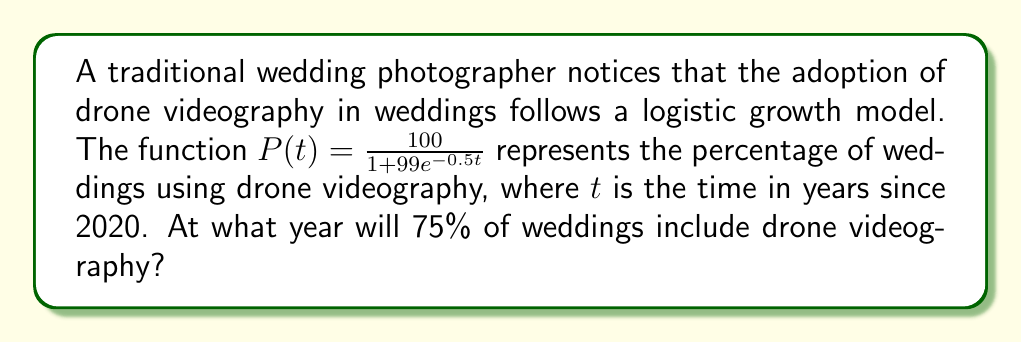Can you answer this question? To solve this problem, we need to follow these steps:

1) The logistic growth function is given by:
   $$P(t) = \frac{100}{1 + 99e^{-0.5t}}$$

2) We want to find when $P(t) = 75$. So, we set up the equation:
   $$75 = \frac{100}{1 + 99e^{-0.5t}}$$

3) Multiply both sides by $(1 + 99e^{-0.5t})$:
   $$75(1 + 99e^{-0.5t}) = 100$$

4) Expand the left side:
   $$75 + 7425e^{-0.5t} = 100$$

5) Subtract 75 from both sides:
   $$7425e^{-0.5t} = 25$$

6) Divide both sides by 7425:
   $$e^{-0.5t} = \frac{25}{7425} = \frac{1}{297}$$

7) Take the natural log of both sides:
   $$-0.5t = \ln(\frac{1}{297})$$

8) Divide both sides by -0.5:
   $$t = -\frac{\ln(\frac{1}{297})}{0.5} = \frac{\ln(297)}{0.5} \approx 11.46$$

9) Since $t$ is the number of years since 2020, we add 11.46 to 2020:
   $$2020 + 11.46 \approx 2031.46$$

Therefore, 75% of weddings will include drone videography around the middle of 2031.
Answer: Mid-2031 